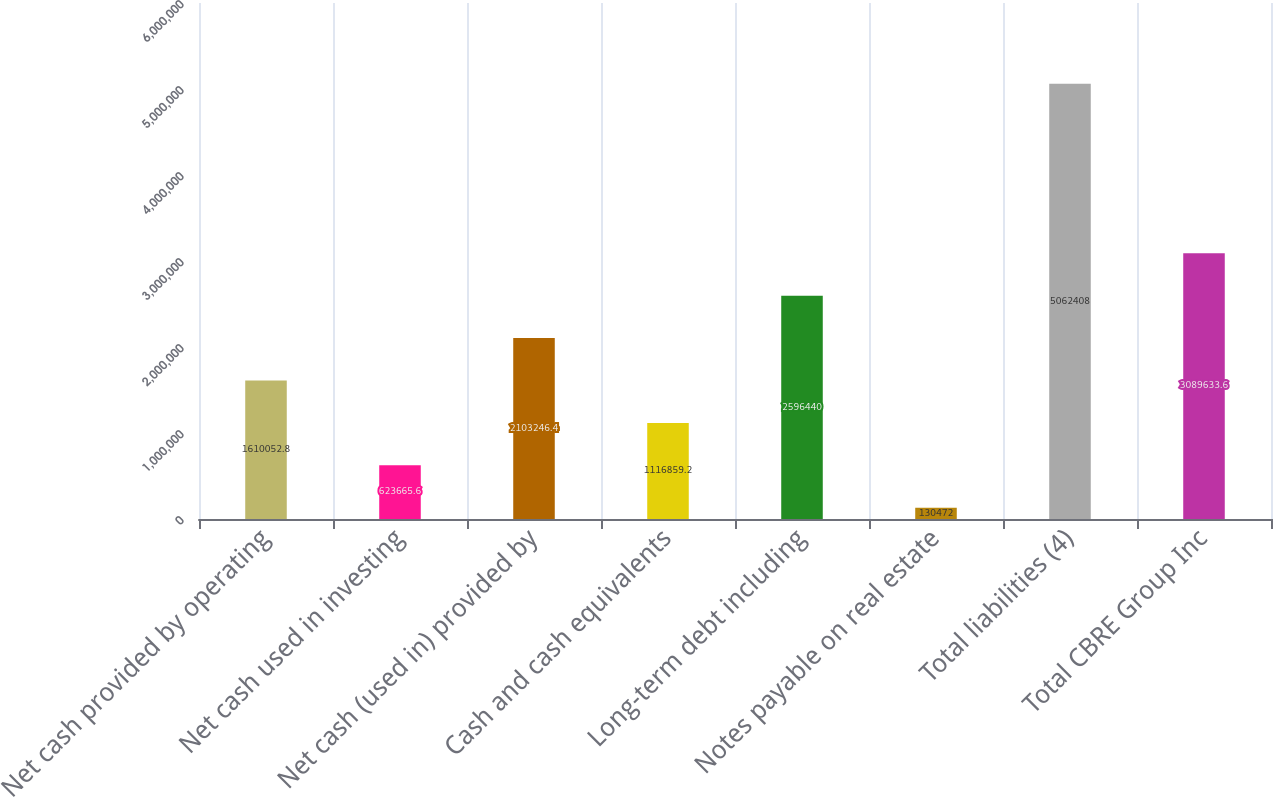Convert chart to OTSL. <chart><loc_0><loc_0><loc_500><loc_500><bar_chart><fcel>Net cash provided by operating<fcel>Net cash used in investing<fcel>Net cash (used in) provided by<fcel>Cash and cash equivalents<fcel>Long-term debt including<fcel>Notes payable on real estate<fcel>Total liabilities (4)<fcel>Total CBRE Group Inc<nl><fcel>1.61005e+06<fcel>623666<fcel>2.10325e+06<fcel>1.11686e+06<fcel>2.59644e+06<fcel>130472<fcel>5.06241e+06<fcel>3.08963e+06<nl></chart> 